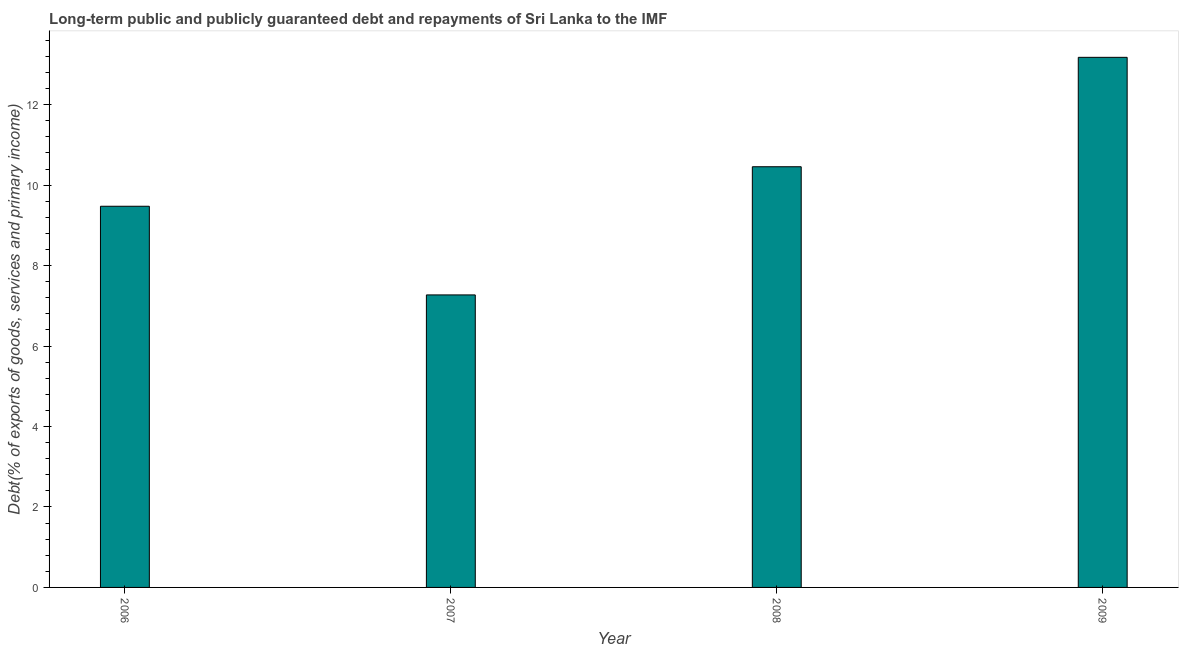Does the graph contain any zero values?
Provide a short and direct response. No. What is the title of the graph?
Offer a terse response. Long-term public and publicly guaranteed debt and repayments of Sri Lanka to the IMF. What is the label or title of the X-axis?
Offer a very short reply. Year. What is the label or title of the Y-axis?
Your answer should be very brief. Debt(% of exports of goods, services and primary income). What is the debt service in 2007?
Keep it short and to the point. 7.27. Across all years, what is the maximum debt service?
Give a very brief answer. 13.18. Across all years, what is the minimum debt service?
Offer a terse response. 7.27. In which year was the debt service maximum?
Offer a terse response. 2009. In which year was the debt service minimum?
Your answer should be compact. 2007. What is the sum of the debt service?
Your answer should be very brief. 40.38. What is the difference between the debt service in 2008 and 2009?
Keep it short and to the point. -2.72. What is the average debt service per year?
Make the answer very short. 10.1. What is the median debt service?
Your response must be concise. 9.97. In how many years, is the debt service greater than 6 %?
Make the answer very short. 4. What is the ratio of the debt service in 2006 to that in 2008?
Ensure brevity in your answer.  0.91. Is the debt service in 2007 less than that in 2008?
Provide a succinct answer. Yes. What is the difference between the highest and the second highest debt service?
Make the answer very short. 2.72. Is the sum of the debt service in 2008 and 2009 greater than the maximum debt service across all years?
Your answer should be very brief. Yes. What is the difference between the highest and the lowest debt service?
Keep it short and to the point. 5.91. How many bars are there?
Give a very brief answer. 4. What is the difference between two consecutive major ticks on the Y-axis?
Make the answer very short. 2. What is the Debt(% of exports of goods, services and primary income) of 2006?
Your answer should be very brief. 9.47. What is the Debt(% of exports of goods, services and primary income) of 2007?
Offer a terse response. 7.27. What is the Debt(% of exports of goods, services and primary income) in 2008?
Your response must be concise. 10.46. What is the Debt(% of exports of goods, services and primary income) in 2009?
Ensure brevity in your answer.  13.18. What is the difference between the Debt(% of exports of goods, services and primary income) in 2006 and 2007?
Give a very brief answer. 2.2. What is the difference between the Debt(% of exports of goods, services and primary income) in 2006 and 2008?
Provide a short and direct response. -0.98. What is the difference between the Debt(% of exports of goods, services and primary income) in 2006 and 2009?
Offer a very short reply. -3.7. What is the difference between the Debt(% of exports of goods, services and primary income) in 2007 and 2008?
Provide a short and direct response. -3.19. What is the difference between the Debt(% of exports of goods, services and primary income) in 2007 and 2009?
Provide a short and direct response. -5.91. What is the difference between the Debt(% of exports of goods, services and primary income) in 2008 and 2009?
Your answer should be very brief. -2.72. What is the ratio of the Debt(% of exports of goods, services and primary income) in 2006 to that in 2007?
Offer a very short reply. 1.3. What is the ratio of the Debt(% of exports of goods, services and primary income) in 2006 to that in 2008?
Offer a terse response. 0.91. What is the ratio of the Debt(% of exports of goods, services and primary income) in 2006 to that in 2009?
Make the answer very short. 0.72. What is the ratio of the Debt(% of exports of goods, services and primary income) in 2007 to that in 2008?
Your answer should be very brief. 0.69. What is the ratio of the Debt(% of exports of goods, services and primary income) in 2007 to that in 2009?
Your answer should be compact. 0.55. What is the ratio of the Debt(% of exports of goods, services and primary income) in 2008 to that in 2009?
Provide a short and direct response. 0.79. 